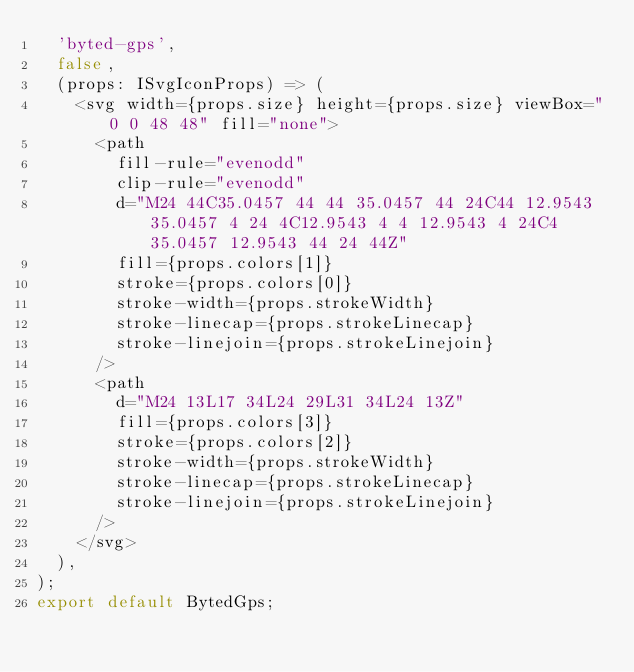<code> <loc_0><loc_0><loc_500><loc_500><_TypeScript_>  'byted-gps',
  false,
  (props: ISvgIconProps) => (
    <svg width={props.size} height={props.size} viewBox="0 0 48 48" fill="none">
      <path
        fill-rule="evenodd"
        clip-rule="evenodd"
        d="M24 44C35.0457 44 44 35.0457 44 24C44 12.9543 35.0457 4 24 4C12.9543 4 4 12.9543 4 24C4 35.0457 12.9543 44 24 44Z"
        fill={props.colors[1]}
        stroke={props.colors[0]}
        stroke-width={props.strokeWidth}
        stroke-linecap={props.strokeLinecap}
        stroke-linejoin={props.strokeLinejoin}
      />
      <path
        d="M24 13L17 34L24 29L31 34L24 13Z"
        fill={props.colors[3]}
        stroke={props.colors[2]}
        stroke-width={props.strokeWidth}
        stroke-linecap={props.strokeLinecap}
        stroke-linejoin={props.strokeLinejoin}
      />
    </svg>
  ),
);
export default BytedGps;
</code> 